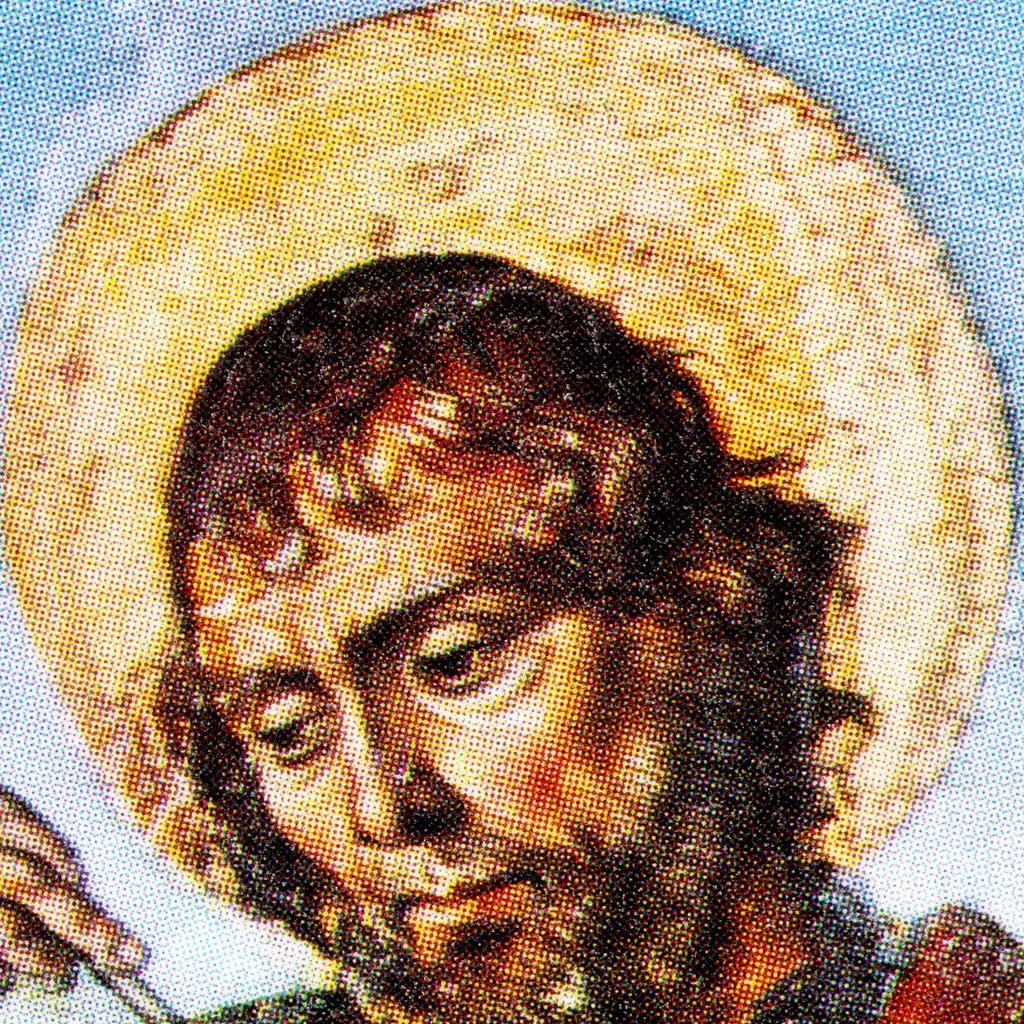How would you summarize this image in a sentence or two? In this image we can see a painting of a person holding an object. 